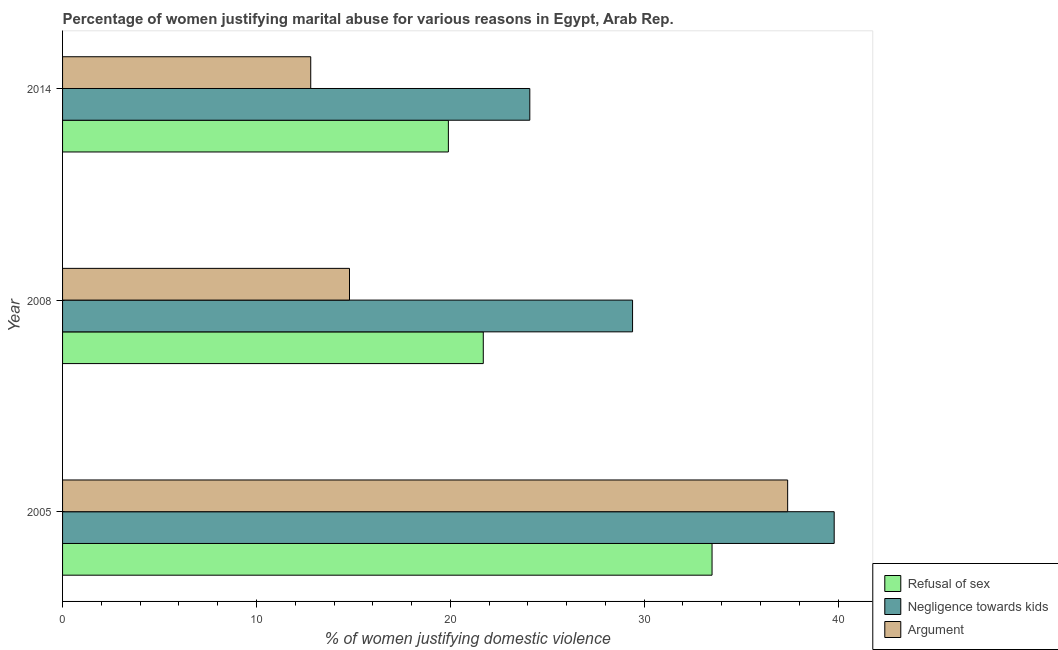How many different coloured bars are there?
Offer a very short reply. 3. How many groups of bars are there?
Keep it short and to the point. 3. Are the number of bars on each tick of the Y-axis equal?
Ensure brevity in your answer.  Yes. How many bars are there on the 3rd tick from the bottom?
Give a very brief answer. 3. What is the percentage of women justifying domestic violence due to negligence towards kids in 2005?
Your answer should be very brief. 39.8. Across all years, what is the maximum percentage of women justifying domestic violence due to arguments?
Give a very brief answer. 37.4. Across all years, what is the minimum percentage of women justifying domestic violence due to negligence towards kids?
Offer a very short reply. 24.1. In which year was the percentage of women justifying domestic violence due to arguments minimum?
Your response must be concise. 2014. What is the total percentage of women justifying domestic violence due to negligence towards kids in the graph?
Ensure brevity in your answer.  93.3. What is the difference between the percentage of women justifying domestic violence due to arguments in 2005 and that in 2014?
Your answer should be compact. 24.6. What is the difference between the percentage of women justifying domestic violence due to refusal of sex in 2005 and the percentage of women justifying domestic violence due to negligence towards kids in 2014?
Your response must be concise. 9.4. What is the average percentage of women justifying domestic violence due to refusal of sex per year?
Your answer should be compact. 25.03. In the year 2014, what is the difference between the percentage of women justifying domestic violence due to arguments and percentage of women justifying domestic violence due to refusal of sex?
Your answer should be compact. -7.1. In how many years, is the percentage of women justifying domestic violence due to refusal of sex greater than 30 %?
Offer a terse response. 1. What is the ratio of the percentage of women justifying domestic violence due to refusal of sex in 2008 to that in 2014?
Your answer should be compact. 1.09. Is the percentage of women justifying domestic violence due to negligence towards kids in 2008 less than that in 2014?
Provide a succinct answer. No. Is the difference between the percentage of women justifying domestic violence due to arguments in 2008 and 2014 greater than the difference between the percentage of women justifying domestic violence due to refusal of sex in 2008 and 2014?
Offer a terse response. Yes. What is the difference between the highest and the second highest percentage of women justifying domestic violence due to arguments?
Provide a short and direct response. 22.6. What is the difference between the highest and the lowest percentage of women justifying domestic violence due to arguments?
Provide a short and direct response. 24.6. In how many years, is the percentage of women justifying domestic violence due to arguments greater than the average percentage of women justifying domestic violence due to arguments taken over all years?
Your answer should be very brief. 1. Is the sum of the percentage of women justifying domestic violence due to refusal of sex in 2005 and 2014 greater than the maximum percentage of women justifying domestic violence due to negligence towards kids across all years?
Your answer should be very brief. Yes. What does the 2nd bar from the top in 2008 represents?
Offer a terse response. Negligence towards kids. What does the 1st bar from the bottom in 2008 represents?
Offer a terse response. Refusal of sex. How many bars are there?
Your answer should be compact. 9. Are the values on the major ticks of X-axis written in scientific E-notation?
Offer a terse response. No. Does the graph contain grids?
Provide a succinct answer. No. Where does the legend appear in the graph?
Make the answer very short. Bottom right. How many legend labels are there?
Your answer should be compact. 3. How are the legend labels stacked?
Keep it short and to the point. Vertical. What is the title of the graph?
Provide a succinct answer. Percentage of women justifying marital abuse for various reasons in Egypt, Arab Rep. Does "Agricultural raw materials" appear as one of the legend labels in the graph?
Your answer should be compact. No. What is the label or title of the X-axis?
Ensure brevity in your answer.  % of women justifying domestic violence. What is the label or title of the Y-axis?
Offer a very short reply. Year. What is the % of women justifying domestic violence of Refusal of sex in 2005?
Provide a short and direct response. 33.5. What is the % of women justifying domestic violence in Negligence towards kids in 2005?
Ensure brevity in your answer.  39.8. What is the % of women justifying domestic violence of Argument in 2005?
Provide a short and direct response. 37.4. What is the % of women justifying domestic violence in Refusal of sex in 2008?
Keep it short and to the point. 21.7. What is the % of women justifying domestic violence of Negligence towards kids in 2008?
Offer a very short reply. 29.4. What is the % of women justifying domestic violence in Negligence towards kids in 2014?
Give a very brief answer. 24.1. Across all years, what is the maximum % of women justifying domestic violence of Refusal of sex?
Your answer should be compact. 33.5. Across all years, what is the maximum % of women justifying domestic violence of Negligence towards kids?
Provide a succinct answer. 39.8. Across all years, what is the maximum % of women justifying domestic violence in Argument?
Make the answer very short. 37.4. Across all years, what is the minimum % of women justifying domestic violence in Refusal of sex?
Provide a succinct answer. 19.9. Across all years, what is the minimum % of women justifying domestic violence of Negligence towards kids?
Make the answer very short. 24.1. What is the total % of women justifying domestic violence of Refusal of sex in the graph?
Offer a very short reply. 75.1. What is the total % of women justifying domestic violence of Negligence towards kids in the graph?
Your answer should be very brief. 93.3. What is the total % of women justifying domestic violence in Argument in the graph?
Your answer should be compact. 65. What is the difference between the % of women justifying domestic violence in Refusal of sex in 2005 and that in 2008?
Your response must be concise. 11.8. What is the difference between the % of women justifying domestic violence of Negligence towards kids in 2005 and that in 2008?
Provide a succinct answer. 10.4. What is the difference between the % of women justifying domestic violence of Argument in 2005 and that in 2008?
Provide a succinct answer. 22.6. What is the difference between the % of women justifying domestic violence in Argument in 2005 and that in 2014?
Your answer should be compact. 24.6. What is the difference between the % of women justifying domestic violence in Refusal of sex in 2008 and that in 2014?
Provide a succinct answer. 1.8. What is the difference between the % of women justifying domestic violence of Refusal of sex in 2005 and the % of women justifying domestic violence of Argument in 2008?
Give a very brief answer. 18.7. What is the difference between the % of women justifying domestic violence of Refusal of sex in 2005 and the % of women justifying domestic violence of Argument in 2014?
Offer a very short reply. 20.7. What is the difference between the % of women justifying domestic violence of Negligence towards kids in 2008 and the % of women justifying domestic violence of Argument in 2014?
Your answer should be compact. 16.6. What is the average % of women justifying domestic violence in Refusal of sex per year?
Make the answer very short. 25.03. What is the average % of women justifying domestic violence of Negligence towards kids per year?
Offer a very short reply. 31.1. What is the average % of women justifying domestic violence of Argument per year?
Provide a succinct answer. 21.67. In the year 2005, what is the difference between the % of women justifying domestic violence of Negligence towards kids and % of women justifying domestic violence of Argument?
Keep it short and to the point. 2.4. In the year 2008, what is the difference between the % of women justifying domestic violence in Negligence towards kids and % of women justifying domestic violence in Argument?
Your answer should be compact. 14.6. What is the ratio of the % of women justifying domestic violence in Refusal of sex in 2005 to that in 2008?
Make the answer very short. 1.54. What is the ratio of the % of women justifying domestic violence of Negligence towards kids in 2005 to that in 2008?
Make the answer very short. 1.35. What is the ratio of the % of women justifying domestic violence in Argument in 2005 to that in 2008?
Your response must be concise. 2.53. What is the ratio of the % of women justifying domestic violence of Refusal of sex in 2005 to that in 2014?
Give a very brief answer. 1.68. What is the ratio of the % of women justifying domestic violence of Negligence towards kids in 2005 to that in 2014?
Keep it short and to the point. 1.65. What is the ratio of the % of women justifying domestic violence of Argument in 2005 to that in 2014?
Offer a terse response. 2.92. What is the ratio of the % of women justifying domestic violence in Refusal of sex in 2008 to that in 2014?
Offer a terse response. 1.09. What is the ratio of the % of women justifying domestic violence of Negligence towards kids in 2008 to that in 2014?
Your answer should be very brief. 1.22. What is the ratio of the % of women justifying domestic violence in Argument in 2008 to that in 2014?
Make the answer very short. 1.16. What is the difference between the highest and the second highest % of women justifying domestic violence of Negligence towards kids?
Ensure brevity in your answer.  10.4. What is the difference between the highest and the second highest % of women justifying domestic violence in Argument?
Your response must be concise. 22.6. What is the difference between the highest and the lowest % of women justifying domestic violence of Negligence towards kids?
Your answer should be very brief. 15.7. What is the difference between the highest and the lowest % of women justifying domestic violence of Argument?
Offer a terse response. 24.6. 